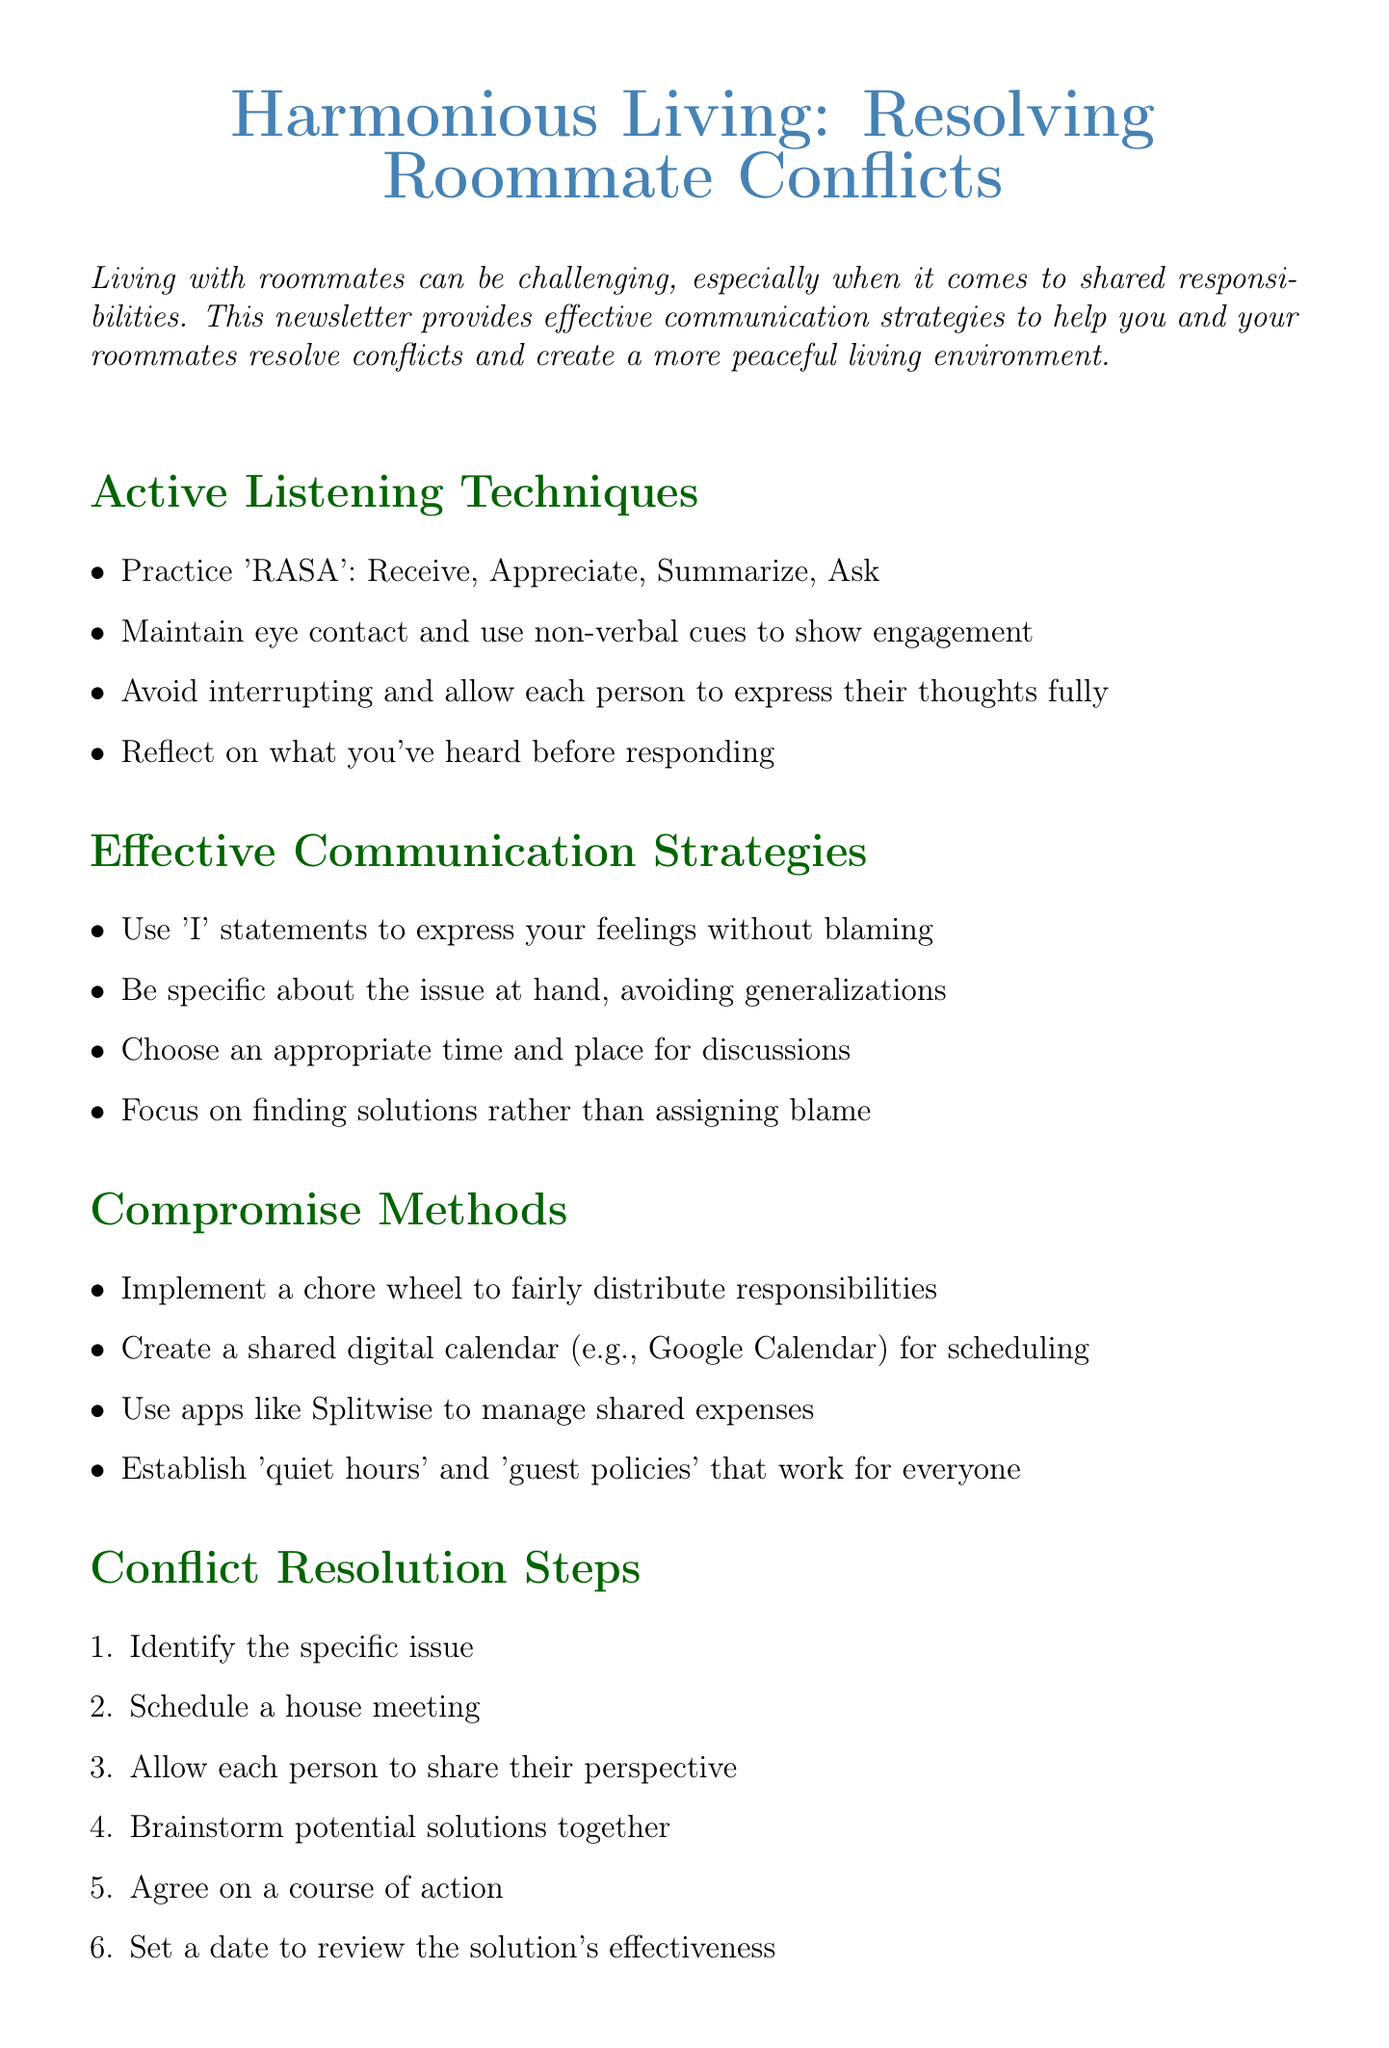What is the title of the newsletter? The title is stated at the beginning of the document, which is "Harmonious Living: Resolving Roommate Conflicts."
Answer: Harmonious Living: Resolving Roommate Conflicts What does 'RASA' stand for? The document mentions 'RASA' as an active listening technique comprising four steps: Receive, Appreciate, Summarize, Ask.
Answer: Receive, Appreciate, Summarize, Ask What is one method suggested for managing shared expenses? The document lists several compromise methods, one of which is to use apps to manage expenses.
Answer: Splitwise What is the first step in the Conflict Resolution Steps? The steps to resolve conflicts begin with identifying the specific issue, as outlined in the document.
Answer: Identify the specific issue How many lessons were learned from the real-life roommate resolution case? The case study lists three lessons learned, which are important takeaways from the example provided.
Answer: Three What is one recommended activity for building a positive roommate relationship? The document suggests organizing monthly bonding activities as a way to strengthen roommate relationships.
Answer: movie nights What type of communication statements should be used to express feelings? The document advises using 'I' statements to express feelings effectively without blaming others.
Answer: 'I' statements How often should house meetings be scheduled? The document does not specify a frequency for meetings, but it implies they should happen regularly for effective communication about issues like chores.
Answer: weekly (as implied by check-ins) Which resource is a comprehensive guide to navigating roommate relationships? The document lists "The Roommate Guidebook" by Mary Beth Storjohann as a resource for navigating roommate relationships.
Answer: The Roommate Guidebook 